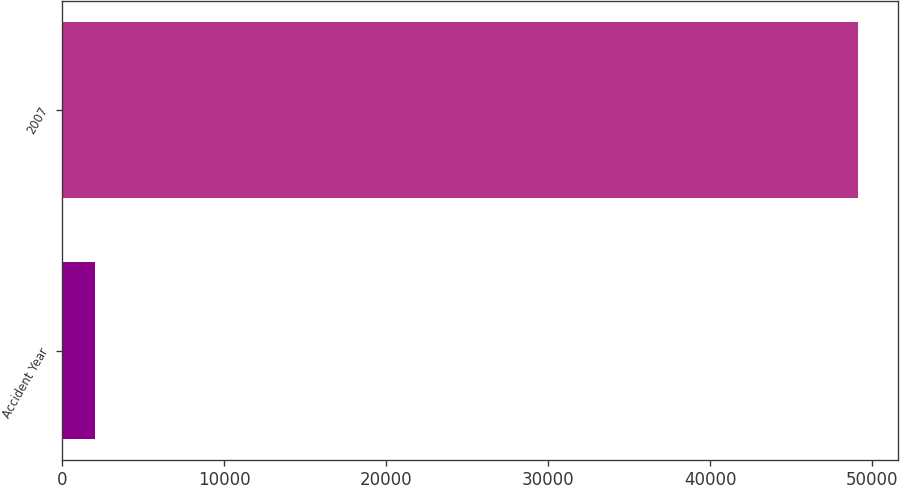<chart> <loc_0><loc_0><loc_500><loc_500><bar_chart><fcel>Accident Year<fcel>2007<nl><fcel>2012<fcel>49129<nl></chart> 